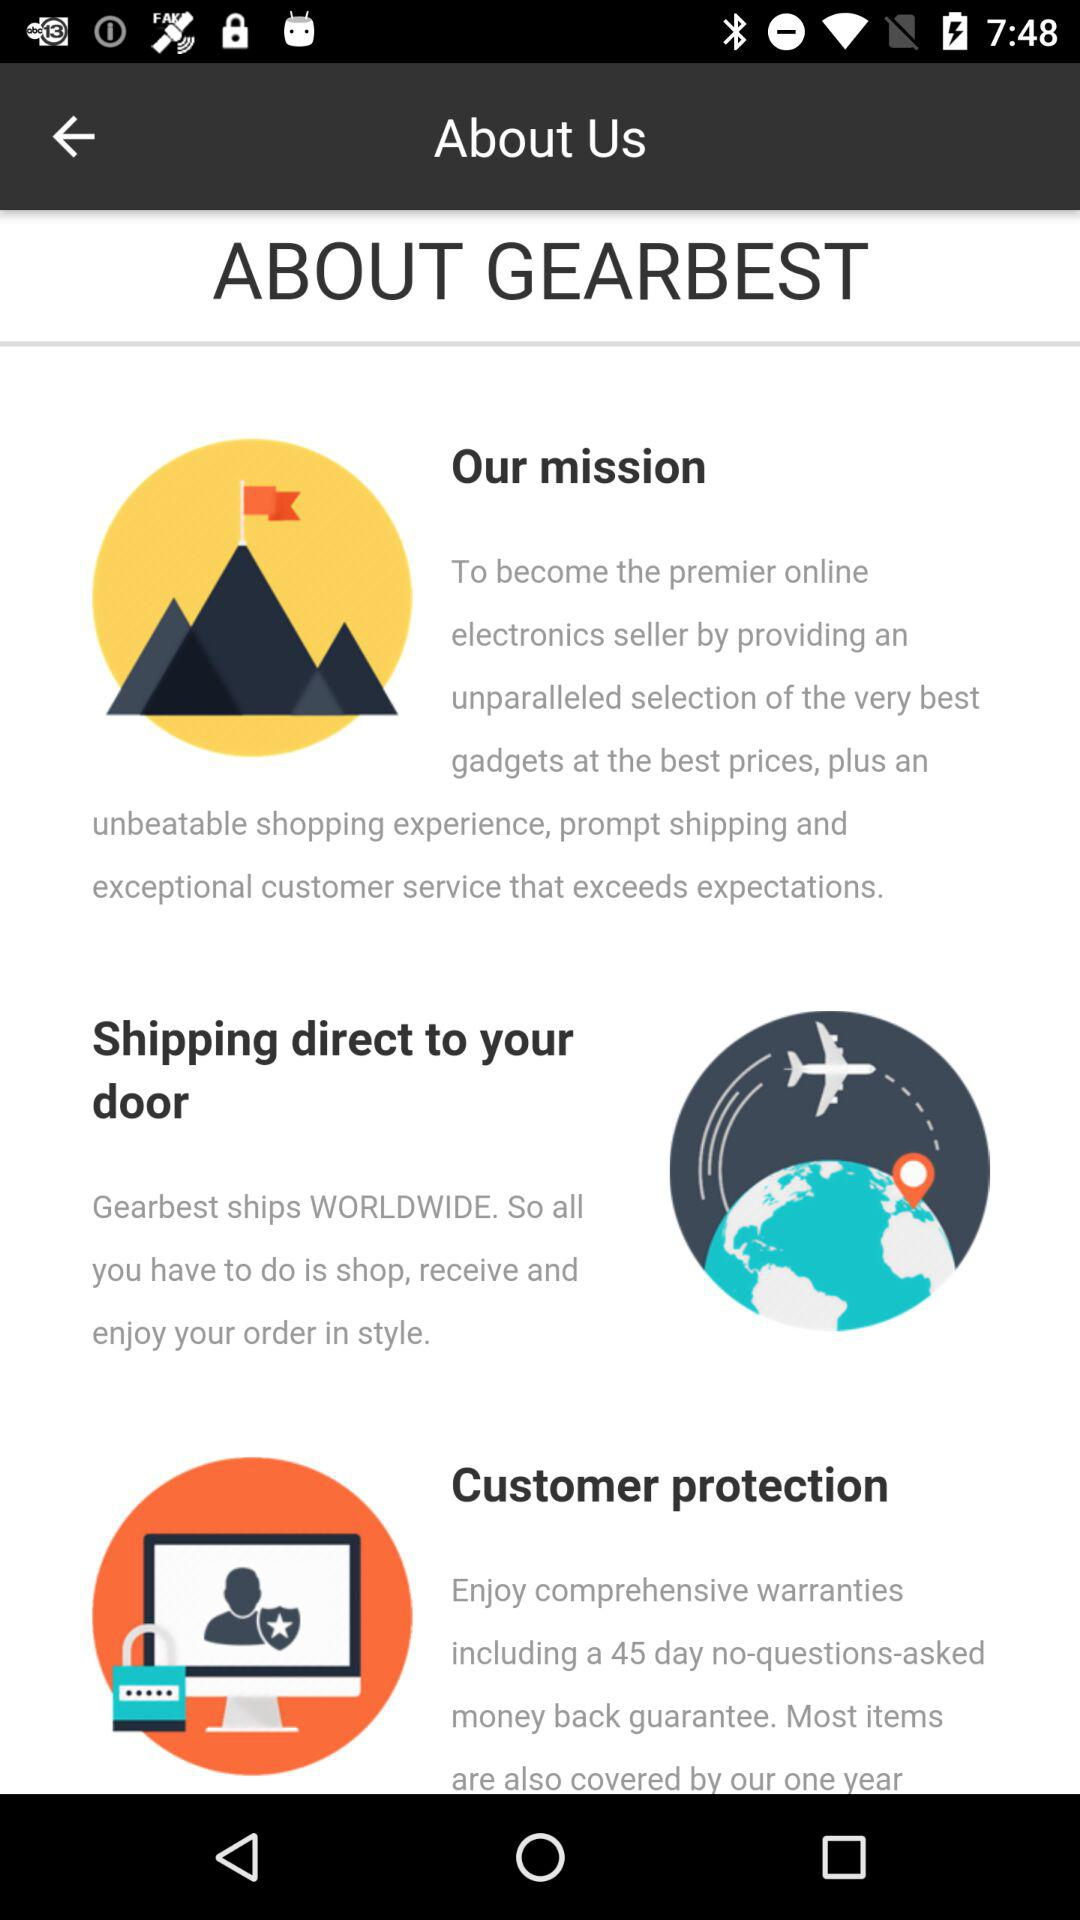Who is this application powered by?
When the provided information is insufficient, respond with <no answer>. <no answer> 